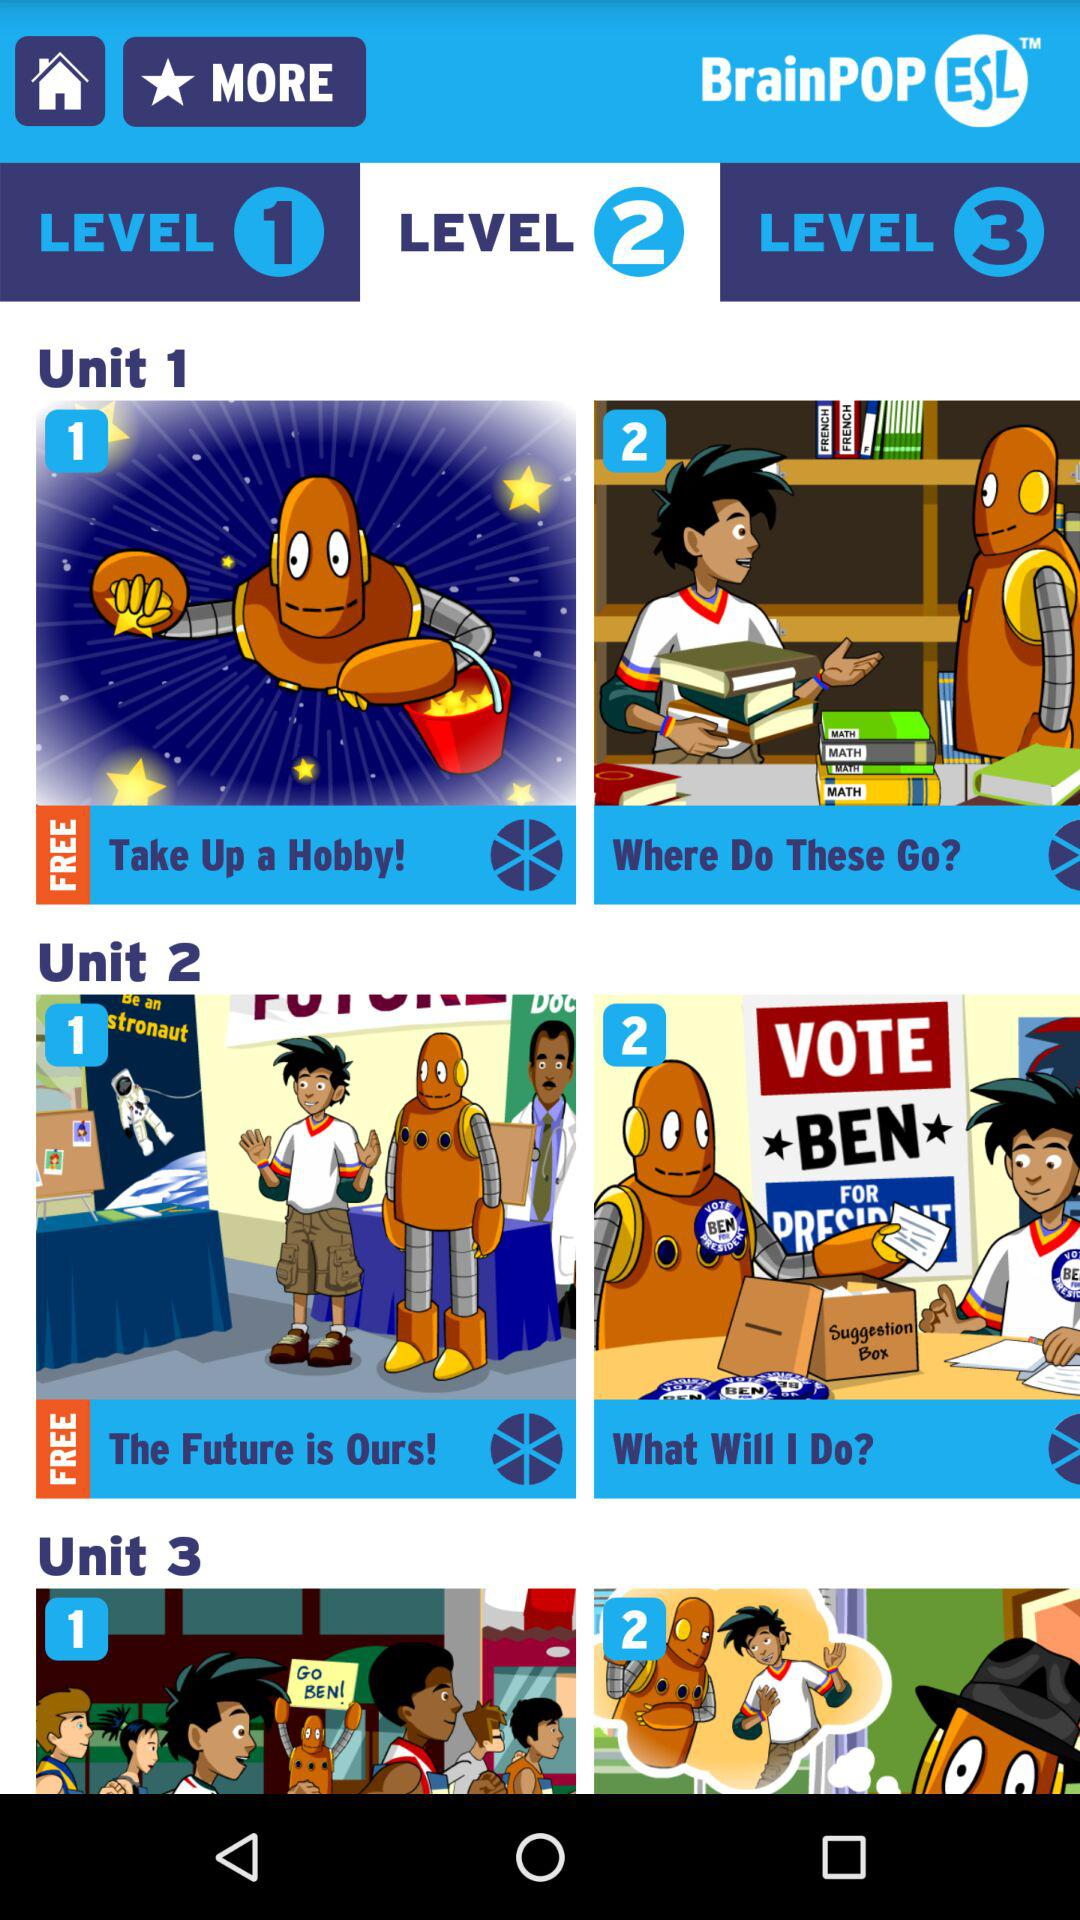Which level has been selected? The level that has been selected is level 2. 